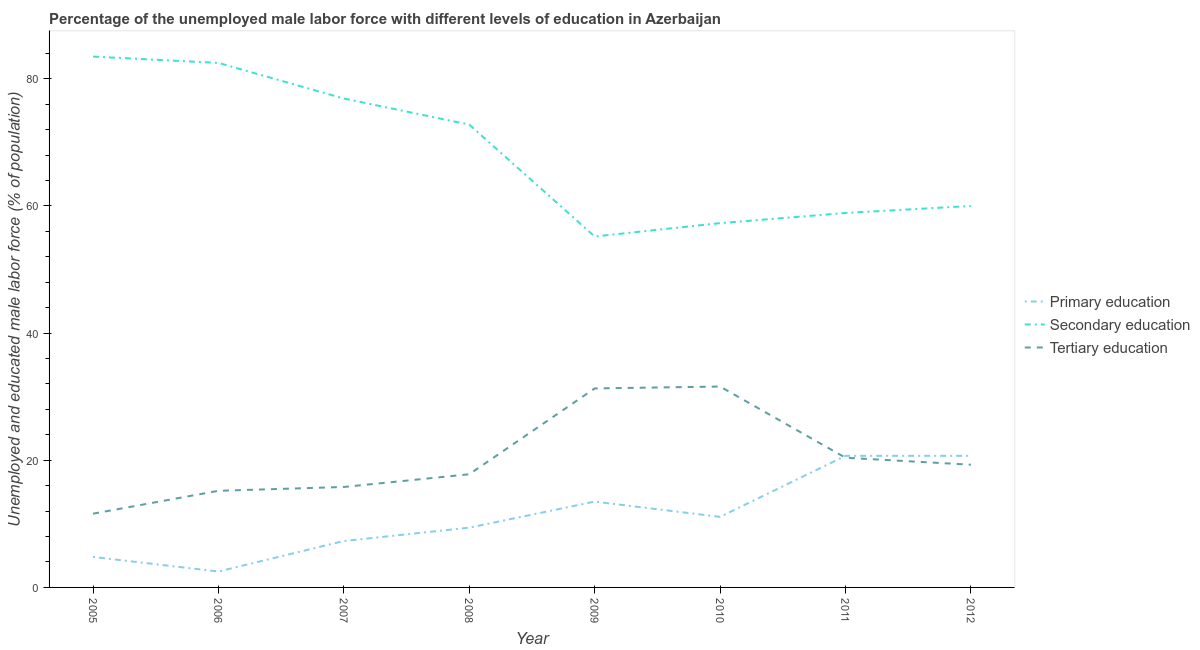Does the line corresponding to percentage of male labor force who received secondary education intersect with the line corresponding to percentage of male labor force who received tertiary education?
Give a very brief answer. No. Is the number of lines equal to the number of legend labels?
Provide a short and direct response. Yes. What is the percentage of male labor force who received primary education in 2008?
Give a very brief answer. 9.4. Across all years, what is the maximum percentage of male labor force who received secondary education?
Make the answer very short. 83.5. Across all years, what is the minimum percentage of male labor force who received primary education?
Your answer should be compact. 2.5. What is the total percentage of male labor force who received tertiary education in the graph?
Give a very brief answer. 163. What is the difference between the percentage of male labor force who received tertiary education in 2009 and that in 2011?
Ensure brevity in your answer.  10.9. What is the difference between the percentage of male labor force who received tertiary education in 2007 and the percentage of male labor force who received secondary education in 2011?
Provide a succinct answer. -43.1. What is the average percentage of male labor force who received secondary education per year?
Offer a terse response. 68.39. In the year 2010, what is the difference between the percentage of male labor force who received primary education and percentage of male labor force who received secondary education?
Keep it short and to the point. -46.2. What is the ratio of the percentage of male labor force who received secondary education in 2010 to that in 2011?
Offer a very short reply. 0.97. Is the difference between the percentage of male labor force who received secondary education in 2005 and 2006 greater than the difference between the percentage of male labor force who received tertiary education in 2005 and 2006?
Your response must be concise. Yes. What is the difference between the highest and the second highest percentage of male labor force who received primary education?
Keep it short and to the point. 0. What is the difference between the highest and the lowest percentage of male labor force who received secondary education?
Ensure brevity in your answer.  28.3. In how many years, is the percentage of male labor force who received primary education greater than the average percentage of male labor force who received primary education taken over all years?
Make the answer very short. 3. Is the sum of the percentage of male labor force who received secondary education in 2005 and 2007 greater than the maximum percentage of male labor force who received tertiary education across all years?
Ensure brevity in your answer.  Yes. Is it the case that in every year, the sum of the percentage of male labor force who received primary education and percentage of male labor force who received secondary education is greater than the percentage of male labor force who received tertiary education?
Ensure brevity in your answer.  Yes. Does the percentage of male labor force who received tertiary education monotonically increase over the years?
Offer a very short reply. No. How many lines are there?
Provide a succinct answer. 3. What is the difference between two consecutive major ticks on the Y-axis?
Your answer should be compact. 20. Are the values on the major ticks of Y-axis written in scientific E-notation?
Provide a short and direct response. No. Does the graph contain any zero values?
Offer a terse response. No. How many legend labels are there?
Your answer should be very brief. 3. What is the title of the graph?
Your answer should be very brief. Percentage of the unemployed male labor force with different levels of education in Azerbaijan. What is the label or title of the Y-axis?
Ensure brevity in your answer.  Unemployed and educated male labor force (% of population). What is the Unemployed and educated male labor force (% of population) of Primary education in 2005?
Offer a very short reply. 4.8. What is the Unemployed and educated male labor force (% of population) of Secondary education in 2005?
Ensure brevity in your answer.  83.5. What is the Unemployed and educated male labor force (% of population) of Tertiary education in 2005?
Your response must be concise. 11.6. What is the Unemployed and educated male labor force (% of population) of Primary education in 2006?
Provide a succinct answer. 2.5. What is the Unemployed and educated male labor force (% of population) in Secondary education in 2006?
Your answer should be compact. 82.5. What is the Unemployed and educated male labor force (% of population) of Tertiary education in 2006?
Offer a very short reply. 15.2. What is the Unemployed and educated male labor force (% of population) in Primary education in 2007?
Keep it short and to the point. 7.3. What is the Unemployed and educated male labor force (% of population) in Secondary education in 2007?
Your response must be concise. 76.9. What is the Unemployed and educated male labor force (% of population) of Tertiary education in 2007?
Offer a very short reply. 15.8. What is the Unemployed and educated male labor force (% of population) in Primary education in 2008?
Offer a terse response. 9.4. What is the Unemployed and educated male labor force (% of population) in Secondary education in 2008?
Keep it short and to the point. 72.8. What is the Unemployed and educated male labor force (% of population) of Tertiary education in 2008?
Give a very brief answer. 17.8. What is the Unemployed and educated male labor force (% of population) of Secondary education in 2009?
Give a very brief answer. 55.2. What is the Unemployed and educated male labor force (% of population) in Tertiary education in 2009?
Your response must be concise. 31.3. What is the Unemployed and educated male labor force (% of population) in Primary education in 2010?
Provide a short and direct response. 11.1. What is the Unemployed and educated male labor force (% of population) of Secondary education in 2010?
Ensure brevity in your answer.  57.3. What is the Unemployed and educated male labor force (% of population) in Tertiary education in 2010?
Offer a very short reply. 31.6. What is the Unemployed and educated male labor force (% of population) in Primary education in 2011?
Make the answer very short. 20.7. What is the Unemployed and educated male labor force (% of population) of Secondary education in 2011?
Provide a short and direct response. 58.9. What is the Unemployed and educated male labor force (% of population) of Tertiary education in 2011?
Your response must be concise. 20.4. What is the Unemployed and educated male labor force (% of population) of Primary education in 2012?
Provide a short and direct response. 20.7. What is the Unemployed and educated male labor force (% of population) of Tertiary education in 2012?
Offer a very short reply. 19.3. Across all years, what is the maximum Unemployed and educated male labor force (% of population) of Primary education?
Your answer should be very brief. 20.7. Across all years, what is the maximum Unemployed and educated male labor force (% of population) in Secondary education?
Your answer should be very brief. 83.5. Across all years, what is the maximum Unemployed and educated male labor force (% of population) of Tertiary education?
Offer a very short reply. 31.6. Across all years, what is the minimum Unemployed and educated male labor force (% of population) of Primary education?
Provide a succinct answer. 2.5. Across all years, what is the minimum Unemployed and educated male labor force (% of population) of Secondary education?
Ensure brevity in your answer.  55.2. Across all years, what is the minimum Unemployed and educated male labor force (% of population) in Tertiary education?
Ensure brevity in your answer.  11.6. What is the total Unemployed and educated male labor force (% of population) of Secondary education in the graph?
Your answer should be very brief. 547.1. What is the total Unemployed and educated male labor force (% of population) in Tertiary education in the graph?
Offer a terse response. 163. What is the difference between the Unemployed and educated male labor force (% of population) in Primary education in 2005 and that in 2006?
Keep it short and to the point. 2.3. What is the difference between the Unemployed and educated male labor force (% of population) in Tertiary education in 2005 and that in 2006?
Your answer should be very brief. -3.6. What is the difference between the Unemployed and educated male labor force (% of population) in Primary education in 2005 and that in 2008?
Make the answer very short. -4.6. What is the difference between the Unemployed and educated male labor force (% of population) of Secondary education in 2005 and that in 2008?
Give a very brief answer. 10.7. What is the difference between the Unemployed and educated male labor force (% of population) of Secondary education in 2005 and that in 2009?
Your answer should be compact. 28.3. What is the difference between the Unemployed and educated male labor force (% of population) of Tertiary education in 2005 and that in 2009?
Offer a terse response. -19.7. What is the difference between the Unemployed and educated male labor force (% of population) of Primary education in 2005 and that in 2010?
Keep it short and to the point. -6.3. What is the difference between the Unemployed and educated male labor force (% of population) in Secondary education in 2005 and that in 2010?
Ensure brevity in your answer.  26.2. What is the difference between the Unemployed and educated male labor force (% of population) of Tertiary education in 2005 and that in 2010?
Ensure brevity in your answer.  -20. What is the difference between the Unemployed and educated male labor force (% of population) in Primary education in 2005 and that in 2011?
Provide a short and direct response. -15.9. What is the difference between the Unemployed and educated male labor force (% of population) of Secondary education in 2005 and that in 2011?
Your answer should be compact. 24.6. What is the difference between the Unemployed and educated male labor force (% of population) in Primary education in 2005 and that in 2012?
Your answer should be very brief. -15.9. What is the difference between the Unemployed and educated male labor force (% of population) in Secondary education in 2005 and that in 2012?
Your answer should be very brief. 23.5. What is the difference between the Unemployed and educated male labor force (% of population) of Primary education in 2006 and that in 2008?
Keep it short and to the point. -6.9. What is the difference between the Unemployed and educated male labor force (% of population) in Primary education in 2006 and that in 2009?
Offer a very short reply. -11. What is the difference between the Unemployed and educated male labor force (% of population) of Secondary education in 2006 and that in 2009?
Make the answer very short. 27.3. What is the difference between the Unemployed and educated male labor force (% of population) of Tertiary education in 2006 and that in 2009?
Provide a succinct answer. -16.1. What is the difference between the Unemployed and educated male labor force (% of population) of Primary education in 2006 and that in 2010?
Keep it short and to the point. -8.6. What is the difference between the Unemployed and educated male labor force (% of population) of Secondary education in 2006 and that in 2010?
Your response must be concise. 25.2. What is the difference between the Unemployed and educated male labor force (% of population) in Tertiary education in 2006 and that in 2010?
Offer a very short reply. -16.4. What is the difference between the Unemployed and educated male labor force (% of population) of Primary education in 2006 and that in 2011?
Provide a short and direct response. -18.2. What is the difference between the Unemployed and educated male labor force (% of population) in Secondary education in 2006 and that in 2011?
Your response must be concise. 23.6. What is the difference between the Unemployed and educated male labor force (% of population) in Tertiary education in 2006 and that in 2011?
Make the answer very short. -5.2. What is the difference between the Unemployed and educated male labor force (% of population) in Primary education in 2006 and that in 2012?
Offer a terse response. -18.2. What is the difference between the Unemployed and educated male labor force (% of population) of Tertiary education in 2006 and that in 2012?
Provide a short and direct response. -4.1. What is the difference between the Unemployed and educated male labor force (% of population) of Primary education in 2007 and that in 2009?
Keep it short and to the point. -6.2. What is the difference between the Unemployed and educated male labor force (% of population) in Secondary education in 2007 and that in 2009?
Your answer should be compact. 21.7. What is the difference between the Unemployed and educated male labor force (% of population) in Tertiary education in 2007 and that in 2009?
Make the answer very short. -15.5. What is the difference between the Unemployed and educated male labor force (% of population) in Primary education in 2007 and that in 2010?
Your answer should be compact. -3.8. What is the difference between the Unemployed and educated male labor force (% of population) of Secondary education in 2007 and that in 2010?
Your answer should be very brief. 19.6. What is the difference between the Unemployed and educated male labor force (% of population) in Tertiary education in 2007 and that in 2010?
Ensure brevity in your answer.  -15.8. What is the difference between the Unemployed and educated male labor force (% of population) in Primary education in 2008 and that in 2009?
Your response must be concise. -4.1. What is the difference between the Unemployed and educated male labor force (% of population) of Secondary education in 2008 and that in 2009?
Offer a terse response. 17.6. What is the difference between the Unemployed and educated male labor force (% of population) of Primary education in 2008 and that in 2010?
Keep it short and to the point. -1.7. What is the difference between the Unemployed and educated male labor force (% of population) in Secondary education in 2008 and that in 2010?
Your answer should be compact. 15.5. What is the difference between the Unemployed and educated male labor force (% of population) in Tertiary education in 2008 and that in 2010?
Provide a succinct answer. -13.8. What is the difference between the Unemployed and educated male labor force (% of population) in Secondary education in 2008 and that in 2011?
Offer a terse response. 13.9. What is the difference between the Unemployed and educated male labor force (% of population) of Tertiary education in 2008 and that in 2011?
Make the answer very short. -2.6. What is the difference between the Unemployed and educated male labor force (% of population) of Primary education in 2008 and that in 2012?
Ensure brevity in your answer.  -11.3. What is the difference between the Unemployed and educated male labor force (% of population) in Secondary education in 2008 and that in 2012?
Give a very brief answer. 12.8. What is the difference between the Unemployed and educated male labor force (% of population) of Tertiary education in 2008 and that in 2012?
Your response must be concise. -1.5. What is the difference between the Unemployed and educated male labor force (% of population) of Secondary education in 2009 and that in 2010?
Make the answer very short. -2.1. What is the difference between the Unemployed and educated male labor force (% of population) of Tertiary education in 2009 and that in 2010?
Give a very brief answer. -0.3. What is the difference between the Unemployed and educated male labor force (% of population) of Primary education in 2009 and that in 2011?
Make the answer very short. -7.2. What is the difference between the Unemployed and educated male labor force (% of population) in Secondary education in 2009 and that in 2011?
Your response must be concise. -3.7. What is the difference between the Unemployed and educated male labor force (% of population) in Tertiary education in 2009 and that in 2011?
Your answer should be very brief. 10.9. What is the difference between the Unemployed and educated male labor force (% of population) of Primary education in 2009 and that in 2012?
Make the answer very short. -7.2. What is the difference between the Unemployed and educated male labor force (% of population) of Secondary education in 2009 and that in 2012?
Provide a short and direct response. -4.8. What is the difference between the Unemployed and educated male labor force (% of population) in Tertiary education in 2009 and that in 2012?
Give a very brief answer. 12. What is the difference between the Unemployed and educated male labor force (% of population) in Primary education in 2010 and that in 2011?
Give a very brief answer. -9.6. What is the difference between the Unemployed and educated male labor force (% of population) in Secondary education in 2010 and that in 2011?
Offer a terse response. -1.6. What is the difference between the Unemployed and educated male labor force (% of population) of Tertiary education in 2010 and that in 2011?
Your response must be concise. 11.2. What is the difference between the Unemployed and educated male labor force (% of population) of Secondary education in 2010 and that in 2012?
Your answer should be very brief. -2.7. What is the difference between the Unemployed and educated male labor force (% of population) of Tertiary education in 2010 and that in 2012?
Offer a very short reply. 12.3. What is the difference between the Unemployed and educated male labor force (% of population) in Primary education in 2011 and that in 2012?
Offer a very short reply. 0. What is the difference between the Unemployed and educated male labor force (% of population) of Secondary education in 2011 and that in 2012?
Your answer should be compact. -1.1. What is the difference between the Unemployed and educated male labor force (% of population) in Tertiary education in 2011 and that in 2012?
Your response must be concise. 1.1. What is the difference between the Unemployed and educated male labor force (% of population) of Primary education in 2005 and the Unemployed and educated male labor force (% of population) of Secondary education in 2006?
Your answer should be compact. -77.7. What is the difference between the Unemployed and educated male labor force (% of population) of Secondary education in 2005 and the Unemployed and educated male labor force (% of population) of Tertiary education in 2006?
Your answer should be compact. 68.3. What is the difference between the Unemployed and educated male labor force (% of population) in Primary education in 2005 and the Unemployed and educated male labor force (% of population) in Secondary education in 2007?
Your response must be concise. -72.1. What is the difference between the Unemployed and educated male labor force (% of population) in Secondary education in 2005 and the Unemployed and educated male labor force (% of population) in Tertiary education in 2007?
Ensure brevity in your answer.  67.7. What is the difference between the Unemployed and educated male labor force (% of population) of Primary education in 2005 and the Unemployed and educated male labor force (% of population) of Secondary education in 2008?
Your response must be concise. -68. What is the difference between the Unemployed and educated male labor force (% of population) in Primary education in 2005 and the Unemployed and educated male labor force (% of population) in Tertiary education in 2008?
Provide a short and direct response. -13. What is the difference between the Unemployed and educated male labor force (% of population) of Secondary education in 2005 and the Unemployed and educated male labor force (% of population) of Tertiary education in 2008?
Keep it short and to the point. 65.7. What is the difference between the Unemployed and educated male labor force (% of population) in Primary education in 2005 and the Unemployed and educated male labor force (% of population) in Secondary education in 2009?
Your answer should be compact. -50.4. What is the difference between the Unemployed and educated male labor force (% of population) in Primary education in 2005 and the Unemployed and educated male labor force (% of population) in Tertiary education in 2009?
Ensure brevity in your answer.  -26.5. What is the difference between the Unemployed and educated male labor force (% of population) in Secondary education in 2005 and the Unemployed and educated male labor force (% of population) in Tertiary education in 2009?
Provide a short and direct response. 52.2. What is the difference between the Unemployed and educated male labor force (% of population) of Primary education in 2005 and the Unemployed and educated male labor force (% of population) of Secondary education in 2010?
Provide a succinct answer. -52.5. What is the difference between the Unemployed and educated male labor force (% of population) in Primary education in 2005 and the Unemployed and educated male labor force (% of population) in Tertiary education in 2010?
Offer a terse response. -26.8. What is the difference between the Unemployed and educated male labor force (% of population) in Secondary education in 2005 and the Unemployed and educated male labor force (% of population) in Tertiary education in 2010?
Offer a very short reply. 51.9. What is the difference between the Unemployed and educated male labor force (% of population) in Primary education in 2005 and the Unemployed and educated male labor force (% of population) in Secondary education in 2011?
Offer a terse response. -54.1. What is the difference between the Unemployed and educated male labor force (% of population) of Primary education in 2005 and the Unemployed and educated male labor force (% of population) of Tertiary education in 2011?
Ensure brevity in your answer.  -15.6. What is the difference between the Unemployed and educated male labor force (% of population) of Secondary education in 2005 and the Unemployed and educated male labor force (% of population) of Tertiary education in 2011?
Make the answer very short. 63.1. What is the difference between the Unemployed and educated male labor force (% of population) in Primary education in 2005 and the Unemployed and educated male labor force (% of population) in Secondary education in 2012?
Provide a short and direct response. -55.2. What is the difference between the Unemployed and educated male labor force (% of population) of Secondary education in 2005 and the Unemployed and educated male labor force (% of population) of Tertiary education in 2012?
Provide a succinct answer. 64.2. What is the difference between the Unemployed and educated male labor force (% of population) in Primary education in 2006 and the Unemployed and educated male labor force (% of population) in Secondary education in 2007?
Make the answer very short. -74.4. What is the difference between the Unemployed and educated male labor force (% of population) in Secondary education in 2006 and the Unemployed and educated male labor force (% of population) in Tertiary education in 2007?
Provide a short and direct response. 66.7. What is the difference between the Unemployed and educated male labor force (% of population) in Primary education in 2006 and the Unemployed and educated male labor force (% of population) in Secondary education in 2008?
Your answer should be compact. -70.3. What is the difference between the Unemployed and educated male labor force (% of population) of Primary education in 2006 and the Unemployed and educated male labor force (% of population) of Tertiary education in 2008?
Your answer should be compact. -15.3. What is the difference between the Unemployed and educated male labor force (% of population) in Secondary education in 2006 and the Unemployed and educated male labor force (% of population) in Tertiary education in 2008?
Make the answer very short. 64.7. What is the difference between the Unemployed and educated male labor force (% of population) in Primary education in 2006 and the Unemployed and educated male labor force (% of population) in Secondary education in 2009?
Offer a very short reply. -52.7. What is the difference between the Unemployed and educated male labor force (% of population) in Primary education in 2006 and the Unemployed and educated male labor force (% of population) in Tertiary education in 2009?
Give a very brief answer. -28.8. What is the difference between the Unemployed and educated male labor force (% of population) in Secondary education in 2006 and the Unemployed and educated male labor force (% of population) in Tertiary education in 2009?
Offer a very short reply. 51.2. What is the difference between the Unemployed and educated male labor force (% of population) in Primary education in 2006 and the Unemployed and educated male labor force (% of population) in Secondary education in 2010?
Give a very brief answer. -54.8. What is the difference between the Unemployed and educated male labor force (% of population) of Primary education in 2006 and the Unemployed and educated male labor force (% of population) of Tertiary education in 2010?
Provide a succinct answer. -29.1. What is the difference between the Unemployed and educated male labor force (% of population) of Secondary education in 2006 and the Unemployed and educated male labor force (% of population) of Tertiary education in 2010?
Make the answer very short. 50.9. What is the difference between the Unemployed and educated male labor force (% of population) in Primary education in 2006 and the Unemployed and educated male labor force (% of population) in Secondary education in 2011?
Offer a terse response. -56.4. What is the difference between the Unemployed and educated male labor force (% of population) in Primary education in 2006 and the Unemployed and educated male labor force (% of population) in Tertiary education in 2011?
Your answer should be very brief. -17.9. What is the difference between the Unemployed and educated male labor force (% of population) of Secondary education in 2006 and the Unemployed and educated male labor force (% of population) of Tertiary education in 2011?
Ensure brevity in your answer.  62.1. What is the difference between the Unemployed and educated male labor force (% of population) of Primary education in 2006 and the Unemployed and educated male labor force (% of population) of Secondary education in 2012?
Make the answer very short. -57.5. What is the difference between the Unemployed and educated male labor force (% of population) in Primary education in 2006 and the Unemployed and educated male labor force (% of population) in Tertiary education in 2012?
Your response must be concise. -16.8. What is the difference between the Unemployed and educated male labor force (% of population) of Secondary education in 2006 and the Unemployed and educated male labor force (% of population) of Tertiary education in 2012?
Your answer should be compact. 63.2. What is the difference between the Unemployed and educated male labor force (% of population) of Primary education in 2007 and the Unemployed and educated male labor force (% of population) of Secondary education in 2008?
Give a very brief answer. -65.5. What is the difference between the Unemployed and educated male labor force (% of population) of Secondary education in 2007 and the Unemployed and educated male labor force (% of population) of Tertiary education in 2008?
Provide a succinct answer. 59.1. What is the difference between the Unemployed and educated male labor force (% of population) of Primary education in 2007 and the Unemployed and educated male labor force (% of population) of Secondary education in 2009?
Ensure brevity in your answer.  -47.9. What is the difference between the Unemployed and educated male labor force (% of population) in Primary education in 2007 and the Unemployed and educated male labor force (% of population) in Tertiary education in 2009?
Keep it short and to the point. -24. What is the difference between the Unemployed and educated male labor force (% of population) in Secondary education in 2007 and the Unemployed and educated male labor force (% of population) in Tertiary education in 2009?
Your answer should be compact. 45.6. What is the difference between the Unemployed and educated male labor force (% of population) in Primary education in 2007 and the Unemployed and educated male labor force (% of population) in Tertiary education in 2010?
Give a very brief answer. -24.3. What is the difference between the Unemployed and educated male labor force (% of population) in Secondary education in 2007 and the Unemployed and educated male labor force (% of population) in Tertiary education in 2010?
Keep it short and to the point. 45.3. What is the difference between the Unemployed and educated male labor force (% of population) in Primary education in 2007 and the Unemployed and educated male labor force (% of population) in Secondary education in 2011?
Your response must be concise. -51.6. What is the difference between the Unemployed and educated male labor force (% of population) in Secondary education in 2007 and the Unemployed and educated male labor force (% of population) in Tertiary education in 2011?
Your answer should be compact. 56.5. What is the difference between the Unemployed and educated male labor force (% of population) of Primary education in 2007 and the Unemployed and educated male labor force (% of population) of Secondary education in 2012?
Keep it short and to the point. -52.7. What is the difference between the Unemployed and educated male labor force (% of population) of Secondary education in 2007 and the Unemployed and educated male labor force (% of population) of Tertiary education in 2012?
Give a very brief answer. 57.6. What is the difference between the Unemployed and educated male labor force (% of population) of Primary education in 2008 and the Unemployed and educated male labor force (% of population) of Secondary education in 2009?
Your response must be concise. -45.8. What is the difference between the Unemployed and educated male labor force (% of population) in Primary education in 2008 and the Unemployed and educated male labor force (% of population) in Tertiary education in 2009?
Give a very brief answer. -21.9. What is the difference between the Unemployed and educated male labor force (% of population) of Secondary education in 2008 and the Unemployed and educated male labor force (% of population) of Tertiary education in 2009?
Provide a succinct answer. 41.5. What is the difference between the Unemployed and educated male labor force (% of population) of Primary education in 2008 and the Unemployed and educated male labor force (% of population) of Secondary education in 2010?
Your response must be concise. -47.9. What is the difference between the Unemployed and educated male labor force (% of population) in Primary education in 2008 and the Unemployed and educated male labor force (% of population) in Tertiary education in 2010?
Keep it short and to the point. -22.2. What is the difference between the Unemployed and educated male labor force (% of population) in Secondary education in 2008 and the Unemployed and educated male labor force (% of population) in Tertiary education in 2010?
Provide a short and direct response. 41.2. What is the difference between the Unemployed and educated male labor force (% of population) in Primary education in 2008 and the Unemployed and educated male labor force (% of population) in Secondary education in 2011?
Your response must be concise. -49.5. What is the difference between the Unemployed and educated male labor force (% of population) in Primary education in 2008 and the Unemployed and educated male labor force (% of population) in Tertiary education in 2011?
Make the answer very short. -11. What is the difference between the Unemployed and educated male labor force (% of population) of Secondary education in 2008 and the Unemployed and educated male labor force (% of population) of Tertiary education in 2011?
Provide a succinct answer. 52.4. What is the difference between the Unemployed and educated male labor force (% of population) in Primary education in 2008 and the Unemployed and educated male labor force (% of population) in Secondary education in 2012?
Provide a succinct answer. -50.6. What is the difference between the Unemployed and educated male labor force (% of population) in Secondary education in 2008 and the Unemployed and educated male labor force (% of population) in Tertiary education in 2012?
Provide a succinct answer. 53.5. What is the difference between the Unemployed and educated male labor force (% of population) in Primary education in 2009 and the Unemployed and educated male labor force (% of population) in Secondary education in 2010?
Offer a very short reply. -43.8. What is the difference between the Unemployed and educated male labor force (% of population) in Primary education in 2009 and the Unemployed and educated male labor force (% of population) in Tertiary education in 2010?
Ensure brevity in your answer.  -18.1. What is the difference between the Unemployed and educated male labor force (% of population) of Secondary education in 2009 and the Unemployed and educated male labor force (% of population) of Tertiary education in 2010?
Offer a very short reply. 23.6. What is the difference between the Unemployed and educated male labor force (% of population) of Primary education in 2009 and the Unemployed and educated male labor force (% of population) of Secondary education in 2011?
Keep it short and to the point. -45.4. What is the difference between the Unemployed and educated male labor force (% of population) of Secondary education in 2009 and the Unemployed and educated male labor force (% of population) of Tertiary education in 2011?
Give a very brief answer. 34.8. What is the difference between the Unemployed and educated male labor force (% of population) of Primary education in 2009 and the Unemployed and educated male labor force (% of population) of Secondary education in 2012?
Provide a short and direct response. -46.5. What is the difference between the Unemployed and educated male labor force (% of population) of Secondary education in 2009 and the Unemployed and educated male labor force (% of population) of Tertiary education in 2012?
Your answer should be very brief. 35.9. What is the difference between the Unemployed and educated male labor force (% of population) of Primary education in 2010 and the Unemployed and educated male labor force (% of population) of Secondary education in 2011?
Ensure brevity in your answer.  -47.8. What is the difference between the Unemployed and educated male labor force (% of population) of Secondary education in 2010 and the Unemployed and educated male labor force (% of population) of Tertiary education in 2011?
Keep it short and to the point. 36.9. What is the difference between the Unemployed and educated male labor force (% of population) in Primary education in 2010 and the Unemployed and educated male labor force (% of population) in Secondary education in 2012?
Ensure brevity in your answer.  -48.9. What is the difference between the Unemployed and educated male labor force (% of population) in Primary education in 2011 and the Unemployed and educated male labor force (% of population) in Secondary education in 2012?
Your answer should be compact. -39.3. What is the difference between the Unemployed and educated male labor force (% of population) of Primary education in 2011 and the Unemployed and educated male labor force (% of population) of Tertiary education in 2012?
Your answer should be compact. 1.4. What is the difference between the Unemployed and educated male labor force (% of population) in Secondary education in 2011 and the Unemployed and educated male labor force (% of population) in Tertiary education in 2012?
Make the answer very short. 39.6. What is the average Unemployed and educated male labor force (% of population) of Primary education per year?
Provide a succinct answer. 11.25. What is the average Unemployed and educated male labor force (% of population) of Secondary education per year?
Make the answer very short. 68.39. What is the average Unemployed and educated male labor force (% of population) in Tertiary education per year?
Your answer should be very brief. 20.38. In the year 2005, what is the difference between the Unemployed and educated male labor force (% of population) in Primary education and Unemployed and educated male labor force (% of population) in Secondary education?
Your answer should be very brief. -78.7. In the year 2005, what is the difference between the Unemployed and educated male labor force (% of population) in Primary education and Unemployed and educated male labor force (% of population) in Tertiary education?
Your response must be concise. -6.8. In the year 2005, what is the difference between the Unemployed and educated male labor force (% of population) of Secondary education and Unemployed and educated male labor force (% of population) of Tertiary education?
Offer a very short reply. 71.9. In the year 2006, what is the difference between the Unemployed and educated male labor force (% of population) in Primary education and Unemployed and educated male labor force (% of population) in Secondary education?
Make the answer very short. -80. In the year 2006, what is the difference between the Unemployed and educated male labor force (% of population) of Secondary education and Unemployed and educated male labor force (% of population) of Tertiary education?
Provide a short and direct response. 67.3. In the year 2007, what is the difference between the Unemployed and educated male labor force (% of population) in Primary education and Unemployed and educated male labor force (% of population) in Secondary education?
Your answer should be very brief. -69.6. In the year 2007, what is the difference between the Unemployed and educated male labor force (% of population) of Primary education and Unemployed and educated male labor force (% of population) of Tertiary education?
Your answer should be very brief. -8.5. In the year 2007, what is the difference between the Unemployed and educated male labor force (% of population) in Secondary education and Unemployed and educated male labor force (% of population) in Tertiary education?
Your response must be concise. 61.1. In the year 2008, what is the difference between the Unemployed and educated male labor force (% of population) in Primary education and Unemployed and educated male labor force (% of population) in Secondary education?
Offer a terse response. -63.4. In the year 2008, what is the difference between the Unemployed and educated male labor force (% of population) of Primary education and Unemployed and educated male labor force (% of population) of Tertiary education?
Ensure brevity in your answer.  -8.4. In the year 2008, what is the difference between the Unemployed and educated male labor force (% of population) of Secondary education and Unemployed and educated male labor force (% of population) of Tertiary education?
Make the answer very short. 55. In the year 2009, what is the difference between the Unemployed and educated male labor force (% of population) of Primary education and Unemployed and educated male labor force (% of population) of Secondary education?
Provide a short and direct response. -41.7. In the year 2009, what is the difference between the Unemployed and educated male labor force (% of population) in Primary education and Unemployed and educated male labor force (% of population) in Tertiary education?
Your answer should be compact. -17.8. In the year 2009, what is the difference between the Unemployed and educated male labor force (% of population) of Secondary education and Unemployed and educated male labor force (% of population) of Tertiary education?
Provide a succinct answer. 23.9. In the year 2010, what is the difference between the Unemployed and educated male labor force (% of population) of Primary education and Unemployed and educated male labor force (% of population) of Secondary education?
Keep it short and to the point. -46.2. In the year 2010, what is the difference between the Unemployed and educated male labor force (% of population) in Primary education and Unemployed and educated male labor force (% of population) in Tertiary education?
Provide a short and direct response. -20.5. In the year 2010, what is the difference between the Unemployed and educated male labor force (% of population) in Secondary education and Unemployed and educated male labor force (% of population) in Tertiary education?
Give a very brief answer. 25.7. In the year 2011, what is the difference between the Unemployed and educated male labor force (% of population) in Primary education and Unemployed and educated male labor force (% of population) in Secondary education?
Provide a short and direct response. -38.2. In the year 2011, what is the difference between the Unemployed and educated male labor force (% of population) of Primary education and Unemployed and educated male labor force (% of population) of Tertiary education?
Give a very brief answer. 0.3. In the year 2011, what is the difference between the Unemployed and educated male labor force (% of population) in Secondary education and Unemployed and educated male labor force (% of population) in Tertiary education?
Make the answer very short. 38.5. In the year 2012, what is the difference between the Unemployed and educated male labor force (% of population) of Primary education and Unemployed and educated male labor force (% of population) of Secondary education?
Your answer should be compact. -39.3. In the year 2012, what is the difference between the Unemployed and educated male labor force (% of population) in Secondary education and Unemployed and educated male labor force (% of population) in Tertiary education?
Offer a terse response. 40.7. What is the ratio of the Unemployed and educated male labor force (% of population) of Primary education in 2005 to that in 2006?
Keep it short and to the point. 1.92. What is the ratio of the Unemployed and educated male labor force (% of population) of Secondary education in 2005 to that in 2006?
Make the answer very short. 1.01. What is the ratio of the Unemployed and educated male labor force (% of population) of Tertiary education in 2005 to that in 2006?
Your answer should be compact. 0.76. What is the ratio of the Unemployed and educated male labor force (% of population) in Primary education in 2005 to that in 2007?
Give a very brief answer. 0.66. What is the ratio of the Unemployed and educated male labor force (% of population) of Secondary education in 2005 to that in 2007?
Ensure brevity in your answer.  1.09. What is the ratio of the Unemployed and educated male labor force (% of population) of Tertiary education in 2005 to that in 2007?
Give a very brief answer. 0.73. What is the ratio of the Unemployed and educated male labor force (% of population) in Primary education in 2005 to that in 2008?
Offer a very short reply. 0.51. What is the ratio of the Unemployed and educated male labor force (% of population) of Secondary education in 2005 to that in 2008?
Your response must be concise. 1.15. What is the ratio of the Unemployed and educated male labor force (% of population) in Tertiary education in 2005 to that in 2008?
Provide a succinct answer. 0.65. What is the ratio of the Unemployed and educated male labor force (% of population) of Primary education in 2005 to that in 2009?
Provide a succinct answer. 0.36. What is the ratio of the Unemployed and educated male labor force (% of population) of Secondary education in 2005 to that in 2009?
Your response must be concise. 1.51. What is the ratio of the Unemployed and educated male labor force (% of population) of Tertiary education in 2005 to that in 2009?
Offer a terse response. 0.37. What is the ratio of the Unemployed and educated male labor force (% of population) of Primary education in 2005 to that in 2010?
Your response must be concise. 0.43. What is the ratio of the Unemployed and educated male labor force (% of population) in Secondary education in 2005 to that in 2010?
Offer a terse response. 1.46. What is the ratio of the Unemployed and educated male labor force (% of population) of Tertiary education in 2005 to that in 2010?
Your response must be concise. 0.37. What is the ratio of the Unemployed and educated male labor force (% of population) in Primary education in 2005 to that in 2011?
Your response must be concise. 0.23. What is the ratio of the Unemployed and educated male labor force (% of population) in Secondary education in 2005 to that in 2011?
Provide a succinct answer. 1.42. What is the ratio of the Unemployed and educated male labor force (% of population) of Tertiary education in 2005 to that in 2011?
Ensure brevity in your answer.  0.57. What is the ratio of the Unemployed and educated male labor force (% of population) in Primary education in 2005 to that in 2012?
Provide a short and direct response. 0.23. What is the ratio of the Unemployed and educated male labor force (% of population) of Secondary education in 2005 to that in 2012?
Offer a very short reply. 1.39. What is the ratio of the Unemployed and educated male labor force (% of population) in Tertiary education in 2005 to that in 2012?
Your answer should be very brief. 0.6. What is the ratio of the Unemployed and educated male labor force (% of population) in Primary education in 2006 to that in 2007?
Your response must be concise. 0.34. What is the ratio of the Unemployed and educated male labor force (% of population) of Secondary education in 2006 to that in 2007?
Provide a succinct answer. 1.07. What is the ratio of the Unemployed and educated male labor force (% of population) in Tertiary education in 2006 to that in 2007?
Offer a very short reply. 0.96. What is the ratio of the Unemployed and educated male labor force (% of population) of Primary education in 2006 to that in 2008?
Provide a succinct answer. 0.27. What is the ratio of the Unemployed and educated male labor force (% of population) of Secondary education in 2006 to that in 2008?
Provide a short and direct response. 1.13. What is the ratio of the Unemployed and educated male labor force (% of population) of Tertiary education in 2006 to that in 2008?
Provide a succinct answer. 0.85. What is the ratio of the Unemployed and educated male labor force (% of population) in Primary education in 2006 to that in 2009?
Your response must be concise. 0.19. What is the ratio of the Unemployed and educated male labor force (% of population) of Secondary education in 2006 to that in 2009?
Give a very brief answer. 1.49. What is the ratio of the Unemployed and educated male labor force (% of population) in Tertiary education in 2006 to that in 2009?
Keep it short and to the point. 0.49. What is the ratio of the Unemployed and educated male labor force (% of population) in Primary education in 2006 to that in 2010?
Make the answer very short. 0.23. What is the ratio of the Unemployed and educated male labor force (% of population) in Secondary education in 2006 to that in 2010?
Keep it short and to the point. 1.44. What is the ratio of the Unemployed and educated male labor force (% of population) in Tertiary education in 2006 to that in 2010?
Ensure brevity in your answer.  0.48. What is the ratio of the Unemployed and educated male labor force (% of population) of Primary education in 2006 to that in 2011?
Offer a terse response. 0.12. What is the ratio of the Unemployed and educated male labor force (% of population) of Secondary education in 2006 to that in 2011?
Your answer should be very brief. 1.4. What is the ratio of the Unemployed and educated male labor force (% of population) of Tertiary education in 2006 to that in 2011?
Your response must be concise. 0.75. What is the ratio of the Unemployed and educated male labor force (% of population) in Primary education in 2006 to that in 2012?
Ensure brevity in your answer.  0.12. What is the ratio of the Unemployed and educated male labor force (% of population) of Secondary education in 2006 to that in 2012?
Give a very brief answer. 1.38. What is the ratio of the Unemployed and educated male labor force (% of population) of Tertiary education in 2006 to that in 2012?
Offer a very short reply. 0.79. What is the ratio of the Unemployed and educated male labor force (% of population) in Primary education in 2007 to that in 2008?
Give a very brief answer. 0.78. What is the ratio of the Unemployed and educated male labor force (% of population) in Secondary education in 2007 to that in 2008?
Your response must be concise. 1.06. What is the ratio of the Unemployed and educated male labor force (% of population) of Tertiary education in 2007 to that in 2008?
Provide a succinct answer. 0.89. What is the ratio of the Unemployed and educated male labor force (% of population) in Primary education in 2007 to that in 2009?
Offer a terse response. 0.54. What is the ratio of the Unemployed and educated male labor force (% of population) in Secondary education in 2007 to that in 2009?
Your answer should be compact. 1.39. What is the ratio of the Unemployed and educated male labor force (% of population) in Tertiary education in 2007 to that in 2009?
Provide a short and direct response. 0.5. What is the ratio of the Unemployed and educated male labor force (% of population) of Primary education in 2007 to that in 2010?
Offer a terse response. 0.66. What is the ratio of the Unemployed and educated male labor force (% of population) of Secondary education in 2007 to that in 2010?
Your answer should be very brief. 1.34. What is the ratio of the Unemployed and educated male labor force (% of population) of Primary education in 2007 to that in 2011?
Keep it short and to the point. 0.35. What is the ratio of the Unemployed and educated male labor force (% of population) of Secondary education in 2007 to that in 2011?
Offer a very short reply. 1.31. What is the ratio of the Unemployed and educated male labor force (% of population) in Tertiary education in 2007 to that in 2011?
Offer a very short reply. 0.77. What is the ratio of the Unemployed and educated male labor force (% of population) in Primary education in 2007 to that in 2012?
Your response must be concise. 0.35. What is the ratio of the Unemployed and educated male labor force (% of population) of Secondary education in 2007 to that in 2012?
Your answer should be very brief. 1.28. What is the ratio of the Unemployed and educated male labor force (% of population) in Tertiary education in 2007 to that in 2012?
Provide a short and direct response. 0.82. What is the ratio of the Unemployed and educated male labor force (% of population) in Primary education in 2008 to that in 2009?
Ensure brevity in your answer.  0.7. What is the ratio of the Unemployed and educated male labor force (% of population) of Secondary education in 2008 to that in 2009?
Your response must be concise. 1.32. What is the ratio of the Unemployed and educated male labor force (% of population) in Tertiary education in 2008 to that in 2009?
Provide a succinct answer. 0.57. What is the ratio of the Unemployed and educated male labor force (% of population) of Primary education in 2008 to that in 2010?
Offer a very short reply. 0.85. What is the ratio of the Unemployed and educated male labor force (% of population) in Secondary education in 2008 to that in 2010?
Make the answer very short. 1.27. What is the ratio of the Unemployed and educated male labor force (% of population) in Tertiary education in 2008 to that in 2010?
Offer a terse response. 0.56. What is the ratio of the Unemployed and educated male labor force (% of population) of Primary education in 2008 to that in 2011?
Your answer should be very brief. 0.45. What is the ratio of the Unemployed and educated male labor force (% of population) of Secondary education in 2008 to that in 2011?
Your answer should be compact. 1.24. What is the ratio of the Unemployed and educated male labor force (% of population) in Tertiary education in 2008 to that in 2011?
Keep it short and to the point. 0.87. What is the ratio of the Unemployed and educated male labor force (% of population) in Primary education in 2008 to that in 2012?
Give a very brief answer. 0.45. What is the ratio of the Unemployed and educated male labor force (% of population) in Secondary education in 2008 to that in 2012?
Offer a terse response. 1.21. What is the ratio of the Unemployed and educated male labor force (% of population) of Tertiary education in 2008 to that in 2012?
Your response must be concise. 0.92. What is the ratio of the Unemployed and educated male labor force (% of population) in Primary education in 2009 to that in 2010?
Make the answer very short. 1.22. What is the ratio of the Unemployed and educated male labor force (% of population) of Secondary education in 2009 to that in 2010?
Offer a terse response. 0.96. What is the ratio of the Unemployed and educated male labor force (% of population) of Tertiary education in 2009 to that in 2010?
Offer a very short reply. 0.99. What is the ratio of the Unemployed and educated male labor force (% of population) of Primary education in 2009 to that in 2011?
Ensure brevity in your answer.  0.65. What is the ratio of the Unemployed and educated male labor force (% of population) of Secondary education in 2009 to that in 2011?
Offer a terse response. 0.94. What is the ratio of the Unemployed and educated male labor force (% of population) in Tertiary education in 2009 to that in 2011?
Keep it short and to the point. 1.53. What is the ratio of the Unemployed and educated male labor force (% of population) of Primary education in 2009 to that in 2012?
Your answer should be very brief. 0.65. What is the ratio of the Unemployed and educated male labor force (% of population) in Secondary education in 2009 to that in 2012?
Your answer should be compact. 0.92. What is the ratio of the Unemployed and educated male labor force (% of population) in Tertiary education in 2009 to that in 2012?
Provide a succinct answer. 1.62. What is the ratio of the Unemployed and educated male labor force (% of population) of Primary education in 2010 to that in 2011?
Ensure brevity in your answer.  0.54. What is the ratio of the Unemployed and educated male labor force (% of population) in Secondary education in 2010 to that in 2011?
Provide a short and direct response. 0.97. What is the ratio of the Unemployed and educated male labor force (% of population) in Tertiary education in 2010 to that in 2011?
Offer a terse response. 1.55. What is the ratio of the Unemployed and educated male labor force (% of population) of Primary education in 2010 to that in 2012?
Your response must be concise. 0.54. What is the ratio of the Unemployed and educated male labor force (% of population) of Secondary education in 2010 to that in 2012?
Offer a very short reply. 0.95. What is the ratio of the Unemployed and educated male labor force (% of population) in Tertiary education in 2010 to that in 2012?
Give a very brief answer. 1.64. What is the ratio of the Unemployed and educated male labor force (% of population) of Primary education in 2011 to that in 2012?
Ensure brevity in your answer.  1. What is the ratio of the Unemployed and educated male labor force (% of population) of Secondary education in 2011 to that in 2012?
Provide a succinct answer. 0.98. What is the ratio of the Unemployed and educated male labor force (% of population) of Tertiary education in 2011 to that in 2012?
Offer a very short reply. 1.06. What is the difference between the highest and the second highest Unemployed and educated male labor force (% of population) in Primary education?
Give a very brief answer. 0. What is the difference between the highest and the lowest Unemployed and educated male labor force (% of population) in Primary education?
Your answer should be compact. 18.2. What is the difference between the highest and the lowest Unemployed and educated male labor force (% of population) in Secondary education?
Offer a terse response. 28.3. 